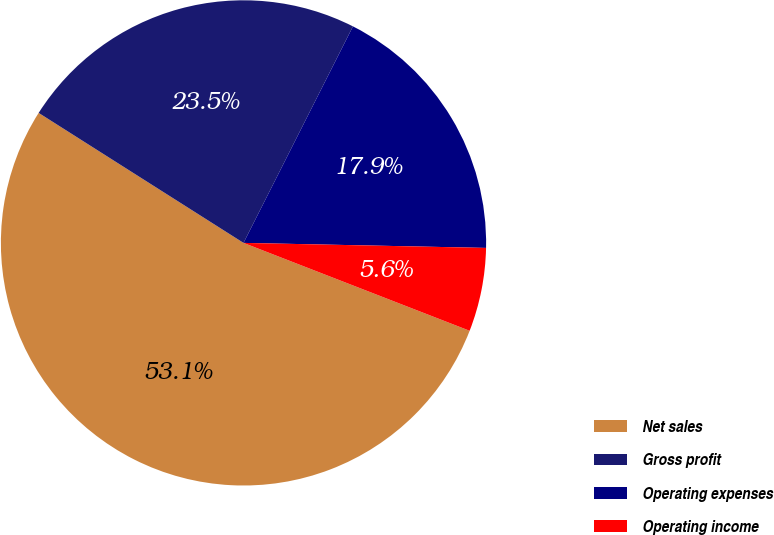Convert chart. <chart><loc_0><loc_0><loc_500><loc_500><pie_chart><fcel>Net sales<fcel>Gross profit<fcel>Operating expenses<fcel>Operating income<nl><fcel>53.1%<fcel>23.45%<fcel>17.88%<fcel>5.57%<nl></chart> 